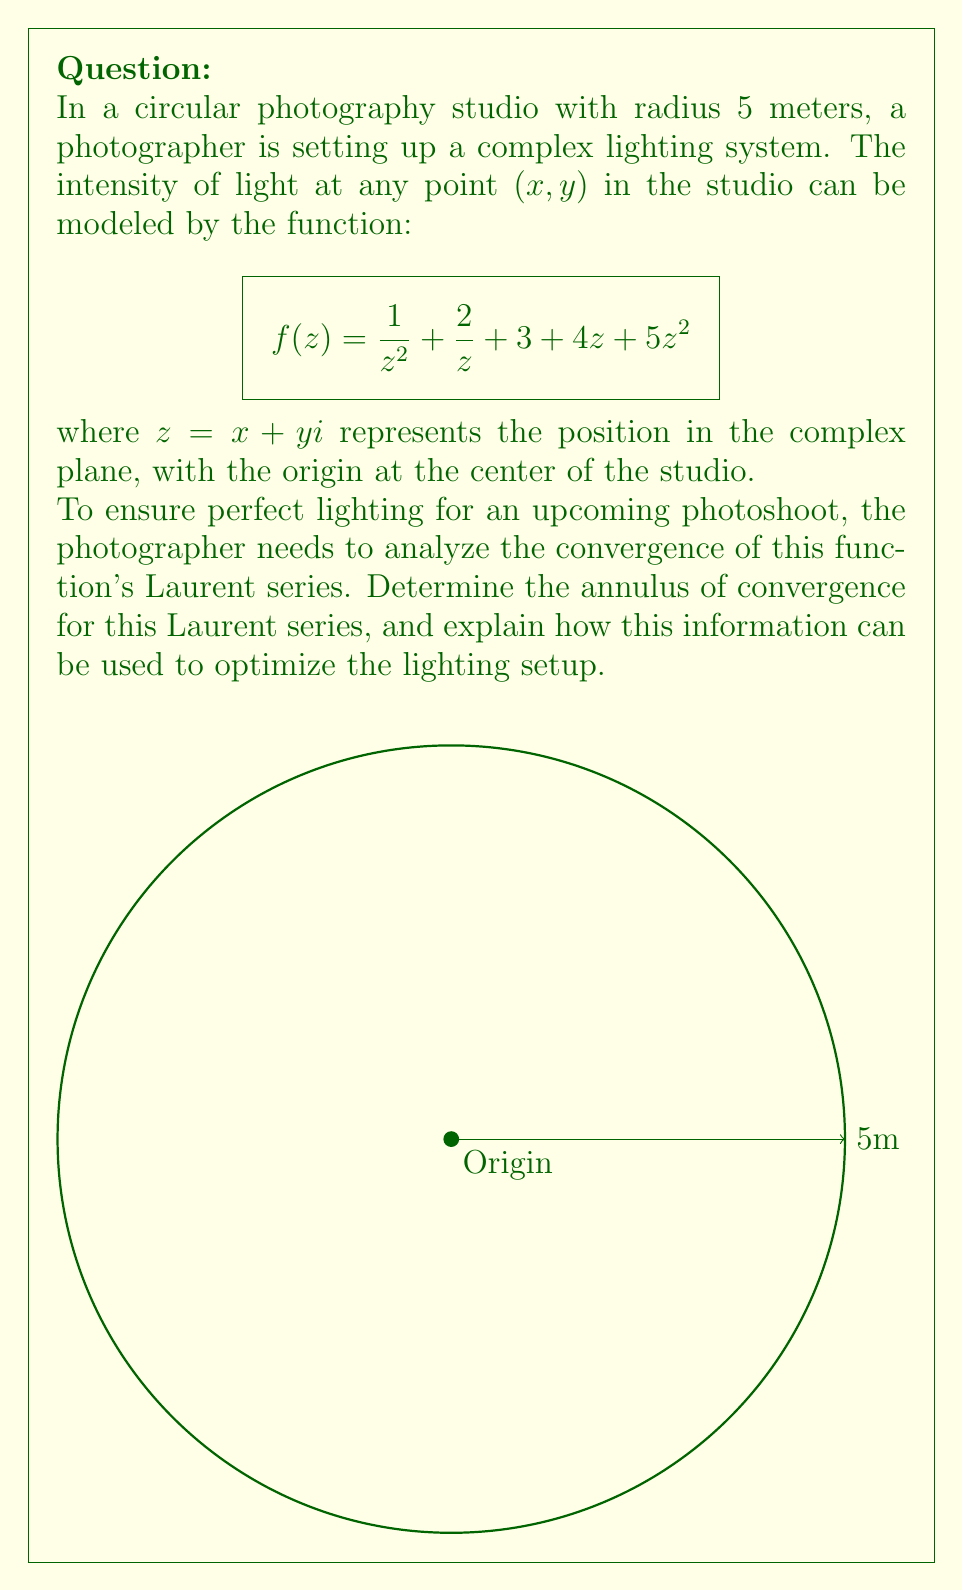Can you answer this question? Let's approach this step-by-step:

1) First, we need to identify the Laurent series of the given function:
   $$f(z) = \frac{1}{z^2} + \frac{2}{z} + 3 + 4z + 5z^2$$

   This is already in the form of a Laurent series, with both positive and negative powers of z.

2) To find the annulus of convergence, we need to determine the inner and outer radii of convergence:

   a) For the inner radius (R_i), we look at the terms with negative powers:
      $\frac{1}{z^2}$ and $\frac{2}{z}$
      The highest negative power is -2, so R_i = 0.

   b) For the outer radius (R_o), we look at the terms with positive powers:
      $4z$ and $5z^2$
      The series will diverge when $|5z^2| \geq 1$, i.e., $|z| \geq \frac{1}{\sqrt{5}}$
      So, R_o = $\frac{1}{\sqrt{5}}$.

3) Therefore, the annulus of convergence is:
   $$0 < |z| < \frac{1}{\sqrt{5}}$$

4) In the context of the photography studio:
   - The function converges for all points except the origin (center of the studio).
   - The lighting intensity becomes unpredictable beyond a radius of $\frac{1}{\sqrt{5}}$ meters (approximately 0.447 meters) from the center.

5) To optimize the lighting setup:
   - The photographer should focus on adjusting lights within the 0.447-meter radius from the center for the most controlled lighting effects.
   - Beyond this radius, additional lighting equipment may be needed to counteract the unpredictable intensity changes.
   - The center point should be avoided for key lighting positions due to the singularity at z = 0.
Answer: Annulus of convergence: $0 < |z| < \frac{1}{\sqrt{5}}$ 